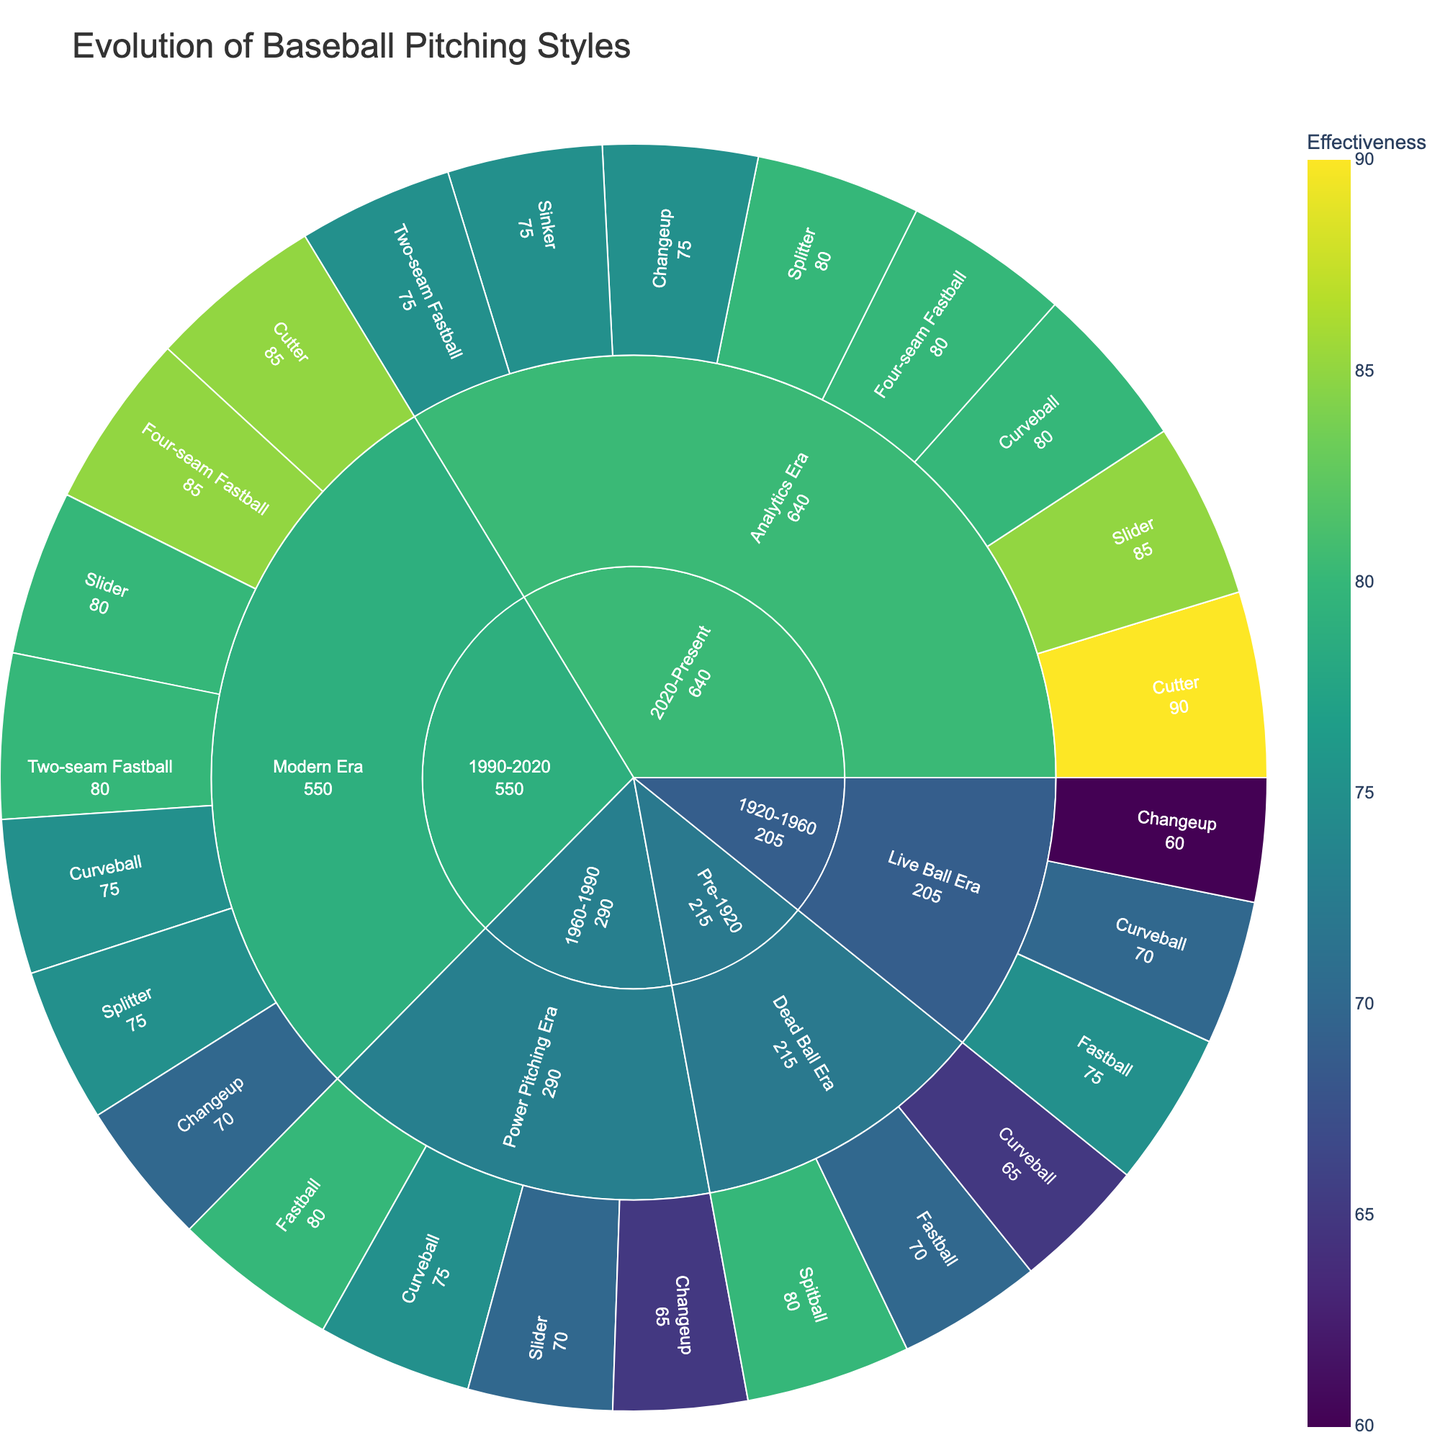what is the title of the plot? The title is usually found at the top of the plot. In this case, it's "Evolution of Baseball Pitching Styles."
Answer: Evolution of Baseball Pitching Styles which era has the highest effectiveness for the spitball? The spitball is visible in the Pre-1920 category under the Dead Ball Era. Its effectiveness is 80, and this pitch type doesn't appear in other eras.
Answer: Pre-1920 (Dead Ball Era) how many pitch types are represented in the Modern Era? Examine the Modern Era section. Count the unique pitch types under this category: Four-seam Fastball, Two-seam Fastball, Curveball, Slider, Changeup, Splitter, Cutter. There are 7 unique pitch types.
Answer: 7 what is the average effectiveness of fastballs in the Power Pitching Era? Identify the effectiveness for fastballs in the Power Pitching Era: Fastball - 80. Since there's only one type of fastball listed, the average effectiveness is the same as its effectiveness.
Answer: 80 which pitch type has the highest effectiveness in the Analytics Era? Look under the Analytics Era section and compare effectiveness values. The Cutter has the highest effectiveness of 90.
Answer: Cutter compare the effectiveness of the Curveball between the Dead Ball Era and the Modern Era Compare the effectiveness values: Dead Ball Era (65) and Modern Era (75). The Curveball is more effective in the Modern Era.
Answer: Modern Era is more effective which category has the highest overall effectiveness, considering the sum of all pitch types within it? Sum the effectiveness values of pitch types in each category and compare:
- Pre-1920: 70+65+80 = 215
- 1920-1960: 75+70+60 = 205
- 1960-1990: 80+75+70+65 = 290
- 1990-2020: 85+80+75+80+70+75+85 = 550
- 2020-Present: 80+75+80+85+75+80+90+75 = 640
  The 2020-Present category has the highest sum (640).
Answer: 2020-Present which pitch type is consistently effective (>=75) across multiple eras? Check pitch types with listed effectiveness for consistency across eras:
- Fastball: 70 (Pre-1920), 75 (1920-1960), 80 (1960-1990)
- Curveball: Varies below 75 in Dead Ball Era
  Key consistent pitches: Fastball, Two-seam Fastball, Four-seam Fastball, Slider, Cutter.
Answer: Cutter (85 in Modern Era, 90 in Analytics Era) what is the effectiveness range for sliders across all eras? Identify effectiveness values for sliders in the Power Pitching Era (70), Modern Era (80), and Analytics Era (85). The range is the difference between the highest and lowest values: 85 - 70 = 15.
Answer: 15 